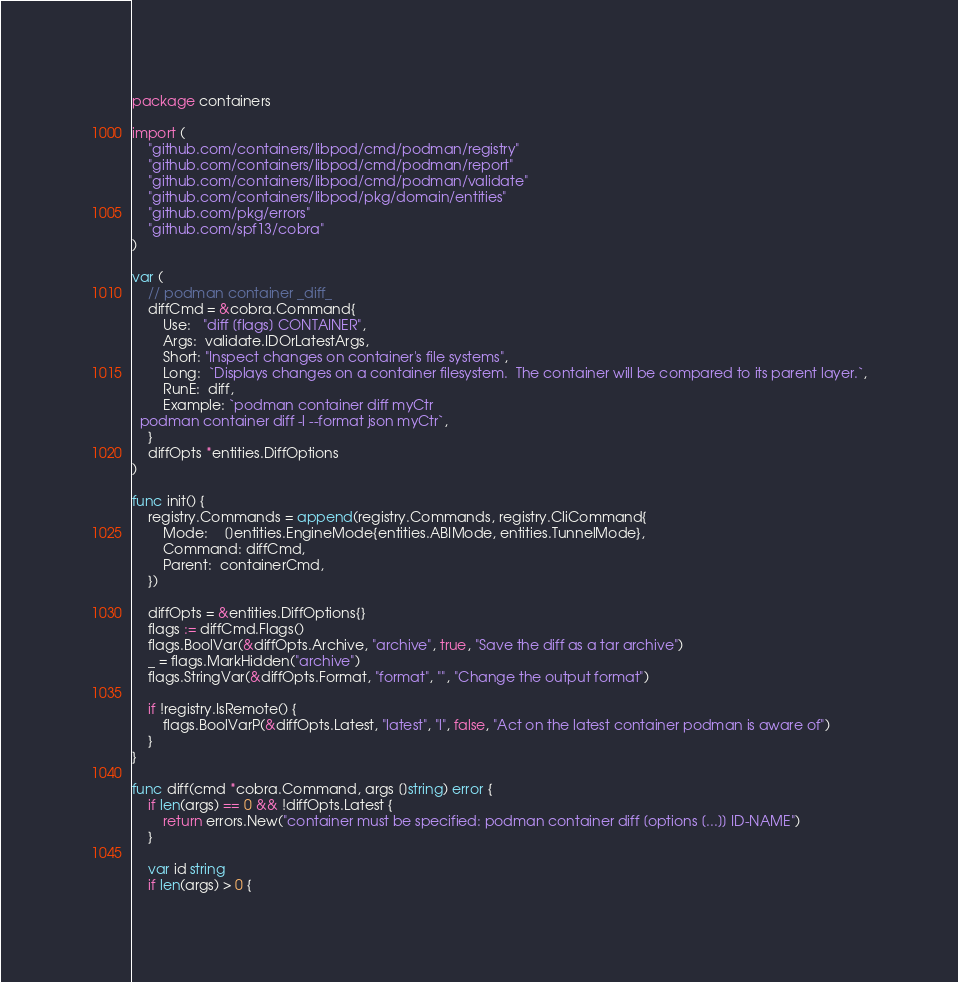<code> <loc_0><loc_0><loc_500><loc_500><_Go_>package containers

import (
	"github.com/containers/libpod/cmd/podman/registry"
	"github.com/containers/libpod/cmd/podman/report"
	"github.com/containers/libpod/cmd/podman/validate"
	"github.com/containers/libpod/pkg/domain/entities"
	"github.com/pkg/errors"
	"github.com/spf13/cobra"
)

var (
	// podman container _diff_
	diffCmd = &cobra.Command{
		Use:   "diff [flags] CONTAINER",
		Args:  validate.IDOrLatestArgs,
		Short: "Inspect changes on container's file systems",
		Long:  `Displays changes on a container filesystem.  The container will be compared to its parent layer.`,
		RunE:  diff,
		Example: `podman container diff myCtr
  podman container diff -l --format json myCtr`,
	}
	diffOpts *entities.DiffOptions
)

func init() {
	registry.Commands = append(registry.Commands, registry.CliCommand{
		Mode:    []entities.EngineMode{entities.ABIMode, entities.TunnelMode},
		Command: diffCmd,
		Parent:  containerCmd,
	})

	diffOpts = &entities.DiffOptions{}
	flags := diffCmd.Flags()
	flags.BoolVar(&diffOpts.Archive, "archive", true, "Save the diff as a tar archive")
	_ = flags.MarkHidden("archive")
	flags.StringVar(&diffOpts.Format, "format", "", "Change the output format")

	if !registry.IsRemote() {
		flags.BoolVarP(&diffOpts.Latest, "latest", "l", false, "Act on the latest container podman is aware of")
	}
}

func diff(cmd *cobra.Command, args []string) error {
	if len(args) == 0 && !diffOpts.Latest {
		return errors.New("container must be specified: podman container diff [options [...]] ID-NAME")
	}

	var id string
	if len(args) > 0 {</code> 